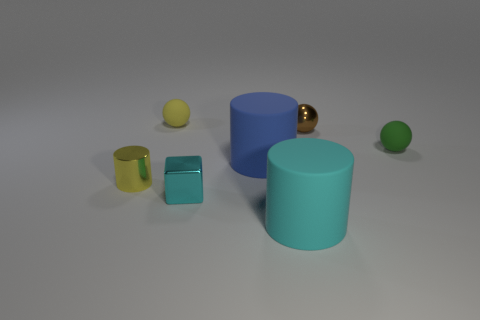Add 2 tiny cyan shiny cubes. How many objects exist? 9 Subtract all spheres. How many objects are left? 4 Add 5 cyan shiny objects. How many cyan shiny objects are left? 6 Add 1 big red rubber balls. How many big red rubber balls exist? 1 Subtract 1 blue cylinders. How many objects are left? 6 Subtract all cyan rubber cylinders. Subtract all big cyan matte things. How many objects are left? 5 